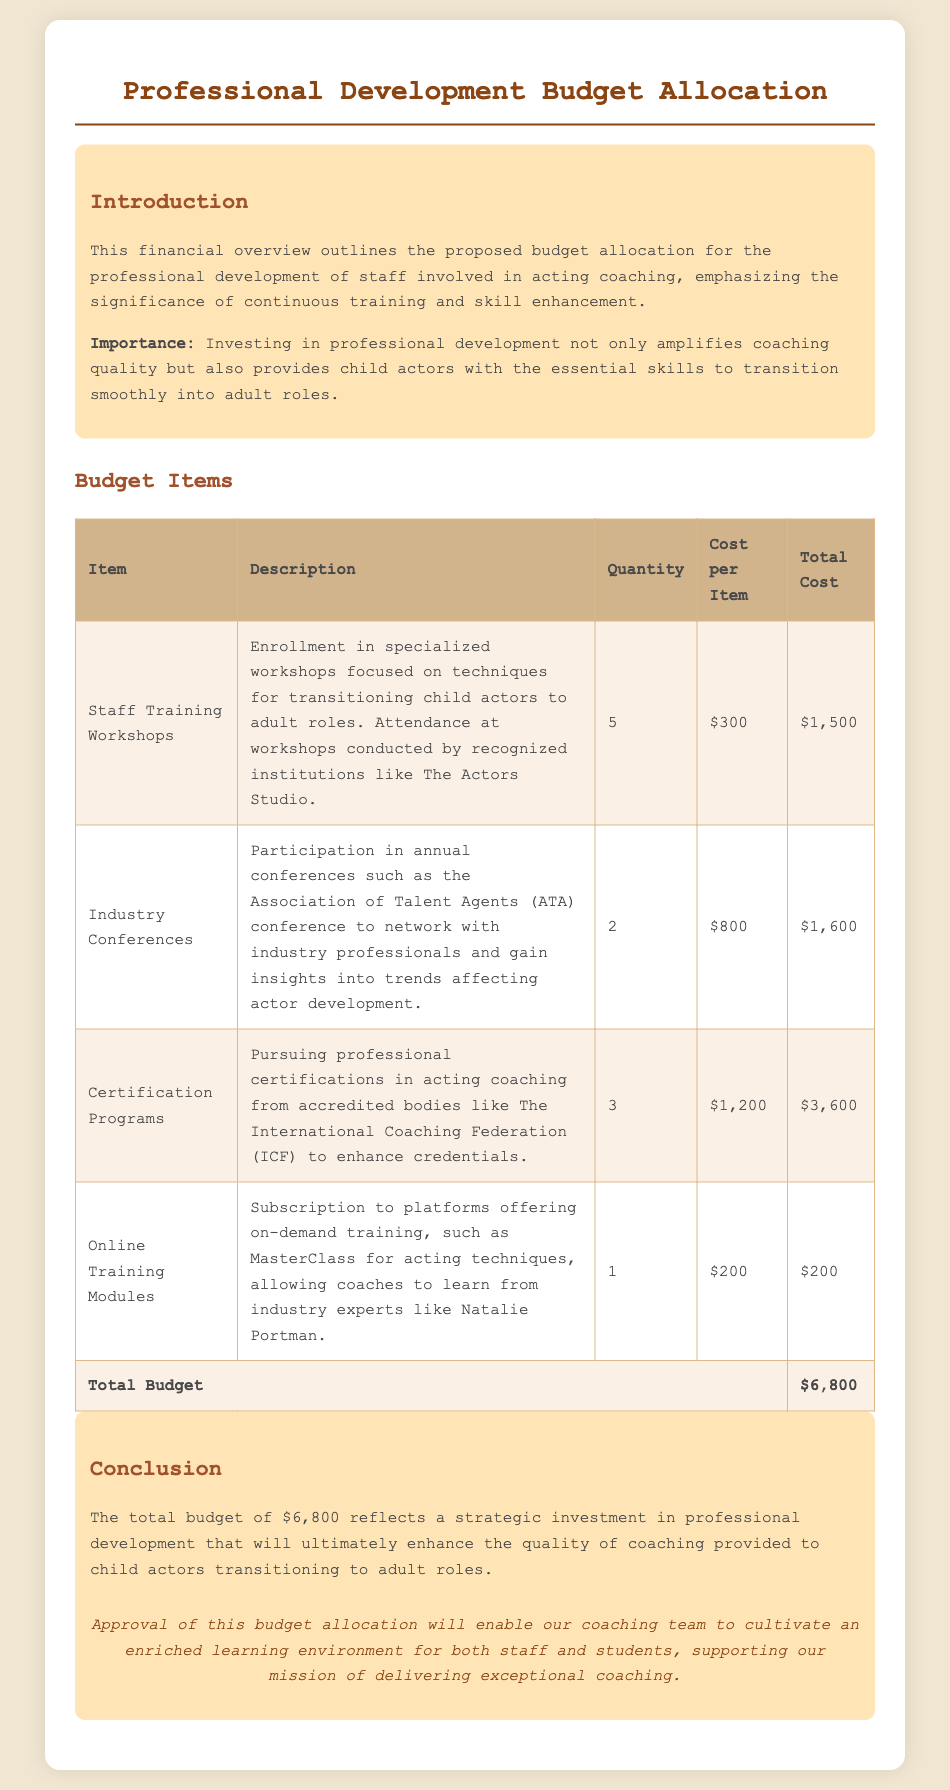what is the total budget? The total budget is presented in the 'Total Budget' row of the table, which is $6,800.
Answer: $6,800 how many item types are listed in the budget? The number of item types can be counted from the table, which lists four different budget items.
Answer: 4 what is the cost per item for the industry conferences? The cost per item for the industry conferences is specified in the table, which is $800.
Answer: $800 which organization provides the certification programs mentioned? The document states that the certification programs are from the International Coaching Federation (ICF).
Answer: International Coaching Federation (ICF) how many workshops are included in the budget allocation? The number of workshops is indicated in the 'Quantity' column for 'Staff Training Workshops', which is 5.
Answer: 5 what is the total cost for the certification programs? The total cost for the certification programs is calculated in the table, totaling $3,600.
Answer: $3,600 what is the significance of investing in professional development? The significance is explained in the introduction section, highlighting the enhancement of coaching quality and supporting child actors' transition to adult roles.
Answer: enhancing coaching quality and supporting transition where are the staff training workshops conducted? The workshops are conducted by recognized institutions, specifically mentioned as The Actors Studio in the description.
Answer: The Actors Studio what type of training is offered through online modules? The online training modules offer subscription-based on-demand training from platforms like MasterClass, focusing on acting techniques.
Answer: MasterClass for acting techniques 